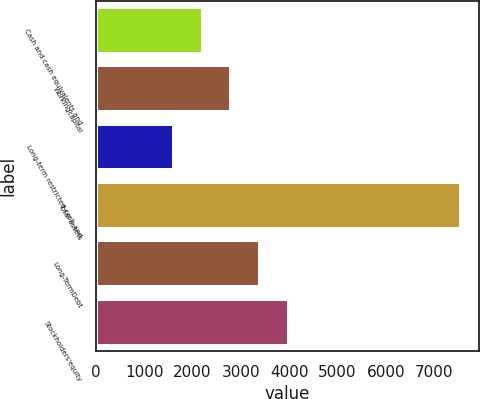Convert chart to OTSL. <chart><loc_0><loc_0><loc_500><loc_500><bar_chart><fcel>Cash and cash equivalents and<fcel>Workingcapital<fcel>Long-term restricted cash and<fcel>Total assets<fcel>Long-TermDebt<fcel>Stockholders'equity<nl><fcel>2208.9<fcel>2802.8<fcel>1615<fcel>7554<fcel>3396.7<fcel>3990.6<nl></chart> 